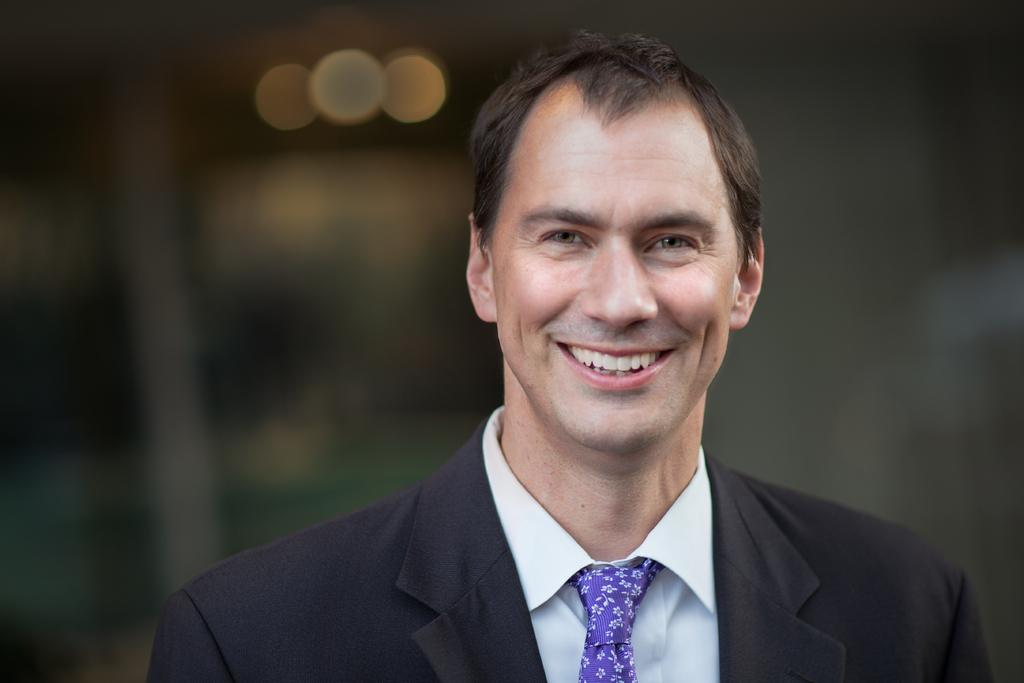Who is present in the image? There is a man in the image. What is the man's facial expression? The man is smiling. What is the man wearing in the image? The man is wearing a suit. What type of ticket does the man have in his hand in the image? There is no ticket present in the image; the man is not holding anything. 